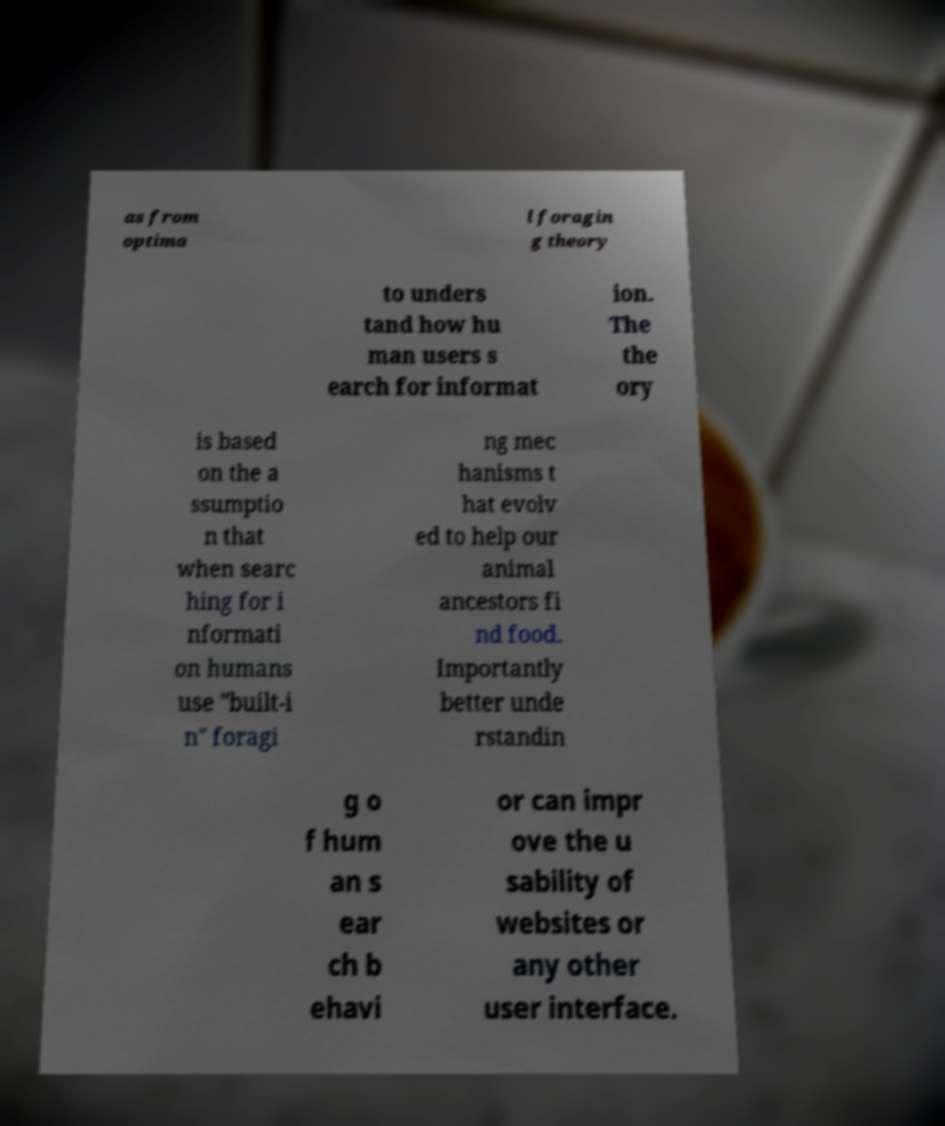Could you assist in decoding the text presented in this image and type it out clearly? as from optima l foragin g theory to unders tand how hu man users s earch for informat ion. The the ory is based on the a ssumptio n that when searc hing for i nformati on humans use "built-i n" foragi ng mec hanisms t hat evolv ed to help our animal ancestors fi nd food. Importantly better unde rstandin g o f hum an s ear ch b ehavi or can impr ove the u sability of websites or any other user interface. 